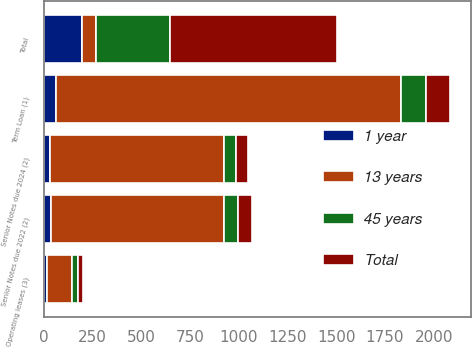Convert chart. <chart><loc_0><loc_0><loc_500><loc_500><stacked_bar_chart><ecel><fcel>Term Loan (1)<fcel>Senior Notes due 2022 (2)<fcel>Senior Notes due 2024 (2)<fcel>Operating leases (3)<fcel>Total<nl><fcel>13 years<fcel>1767.8<fcel>889<fcel>891.3<fcel>127.5<fcel>72<nl><fcel>1 year<fcel>64.4<fcel>37<fcel>31.6<fcel>19.1<fcel>194.9<nl><fcel>45 years<fcel>127.3<fcel>72<fcel>63.3<fcel>31.4<fcel>380.2<nl><fcel>Total<fcel>125.3<fcel>72<fcel>63.3<fcel>26.4<fcel>855.1<nl></chart> 